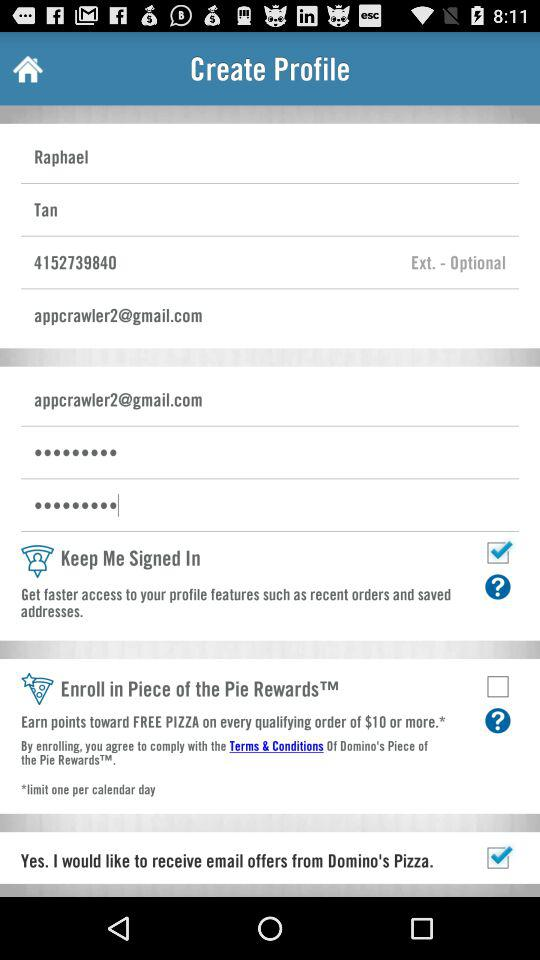What's the phone number? The phone number is 4152739840. 